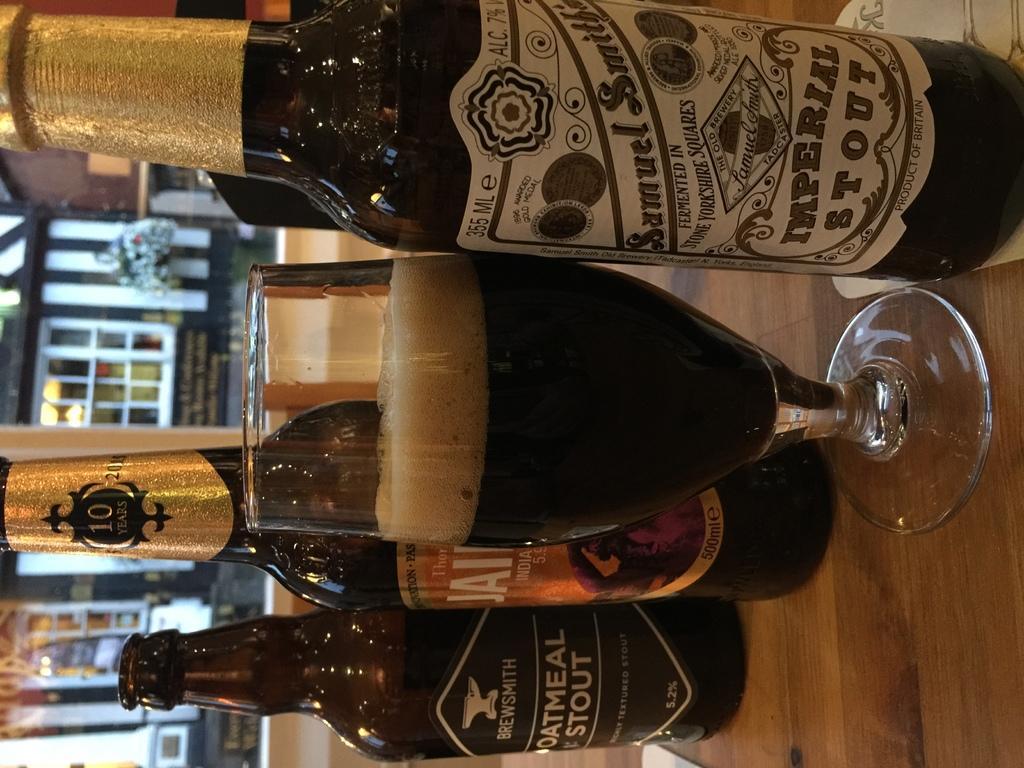Please provide a concise description of this image. In this picture, we can see some bottles and a glass on the surface and in the background, we can see a building with glass-doors. 